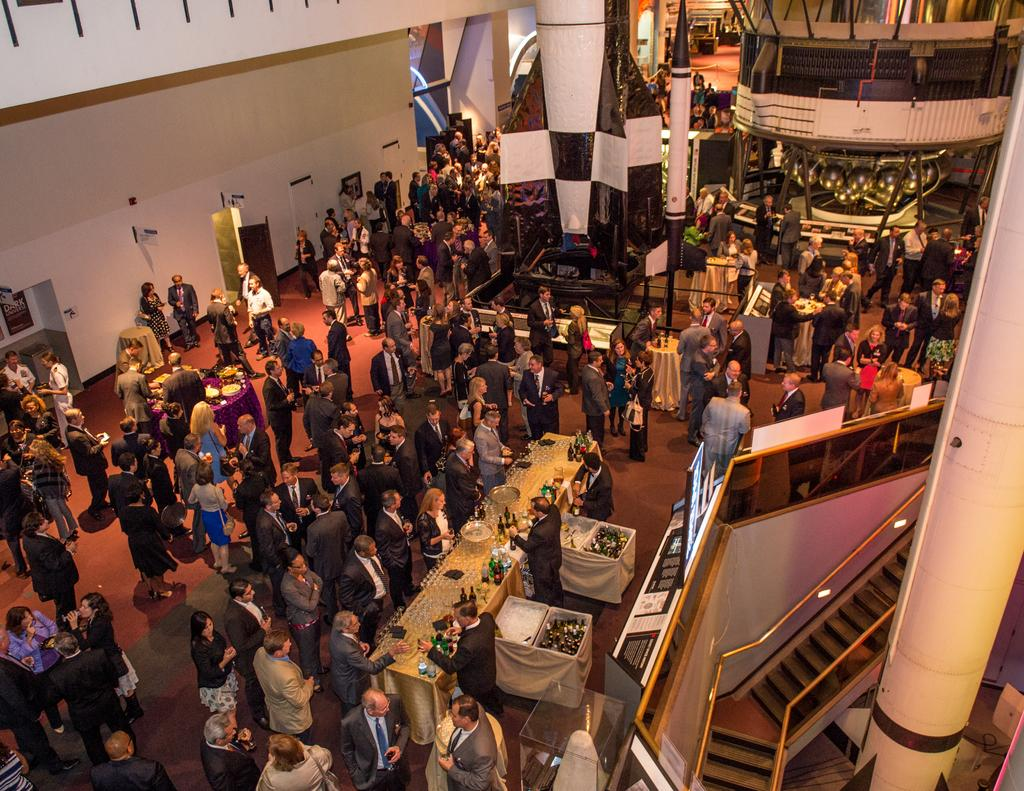How many people are in the image? There is a group of people in the image, but the exact number is not specified. What are the people doing in the image? The people are on the ground, but their specific activity is not mentioned. What type of furniture can be seen in the image? There are tables in the image. What architectural feature is present in the image? There is a staircase in the image. What type of structure is visible in the image? There is a wall in the image. Can you describe any objects in the image? There are some objects in the image, but their specific nature is not mentioned. What type of hole can be seen in the image? There is no hole present in the image. 